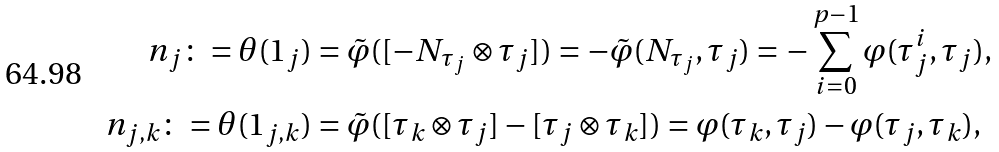Convert formula to latex. <formula><loc_0><loc_0><loc_500><loc_500>n _ { j } \colon = \theta ( 1 _ { j } ) & = \tilde { \varphi } ( [ - N _ { \tau _ { j } } \otimes \tau _ { j } ] ) = - \tilde { \varphi } ( N _ { \tau _ { j } } , \tau _ { j } ) = - \sum _ { i = 0 } ^ { p - 1 } \varphi ( \tau _ { j } ^ { i } , \tau _ { j } ) , \\ n _ { j , k } \colon = \theta ( 1 _ { j , k } ) & = \tilde { \varphi } ( [ \tau _ { k } \otimes \tau _ { j } ] - [ \tau _ { j } \otimes \tau _ { k } ] ) = \varphi ( \tau _ { k } , \tau _ { j } ) - \varphi ( \tau _ { j } , \tau _ { k } ) , \\</formula> 